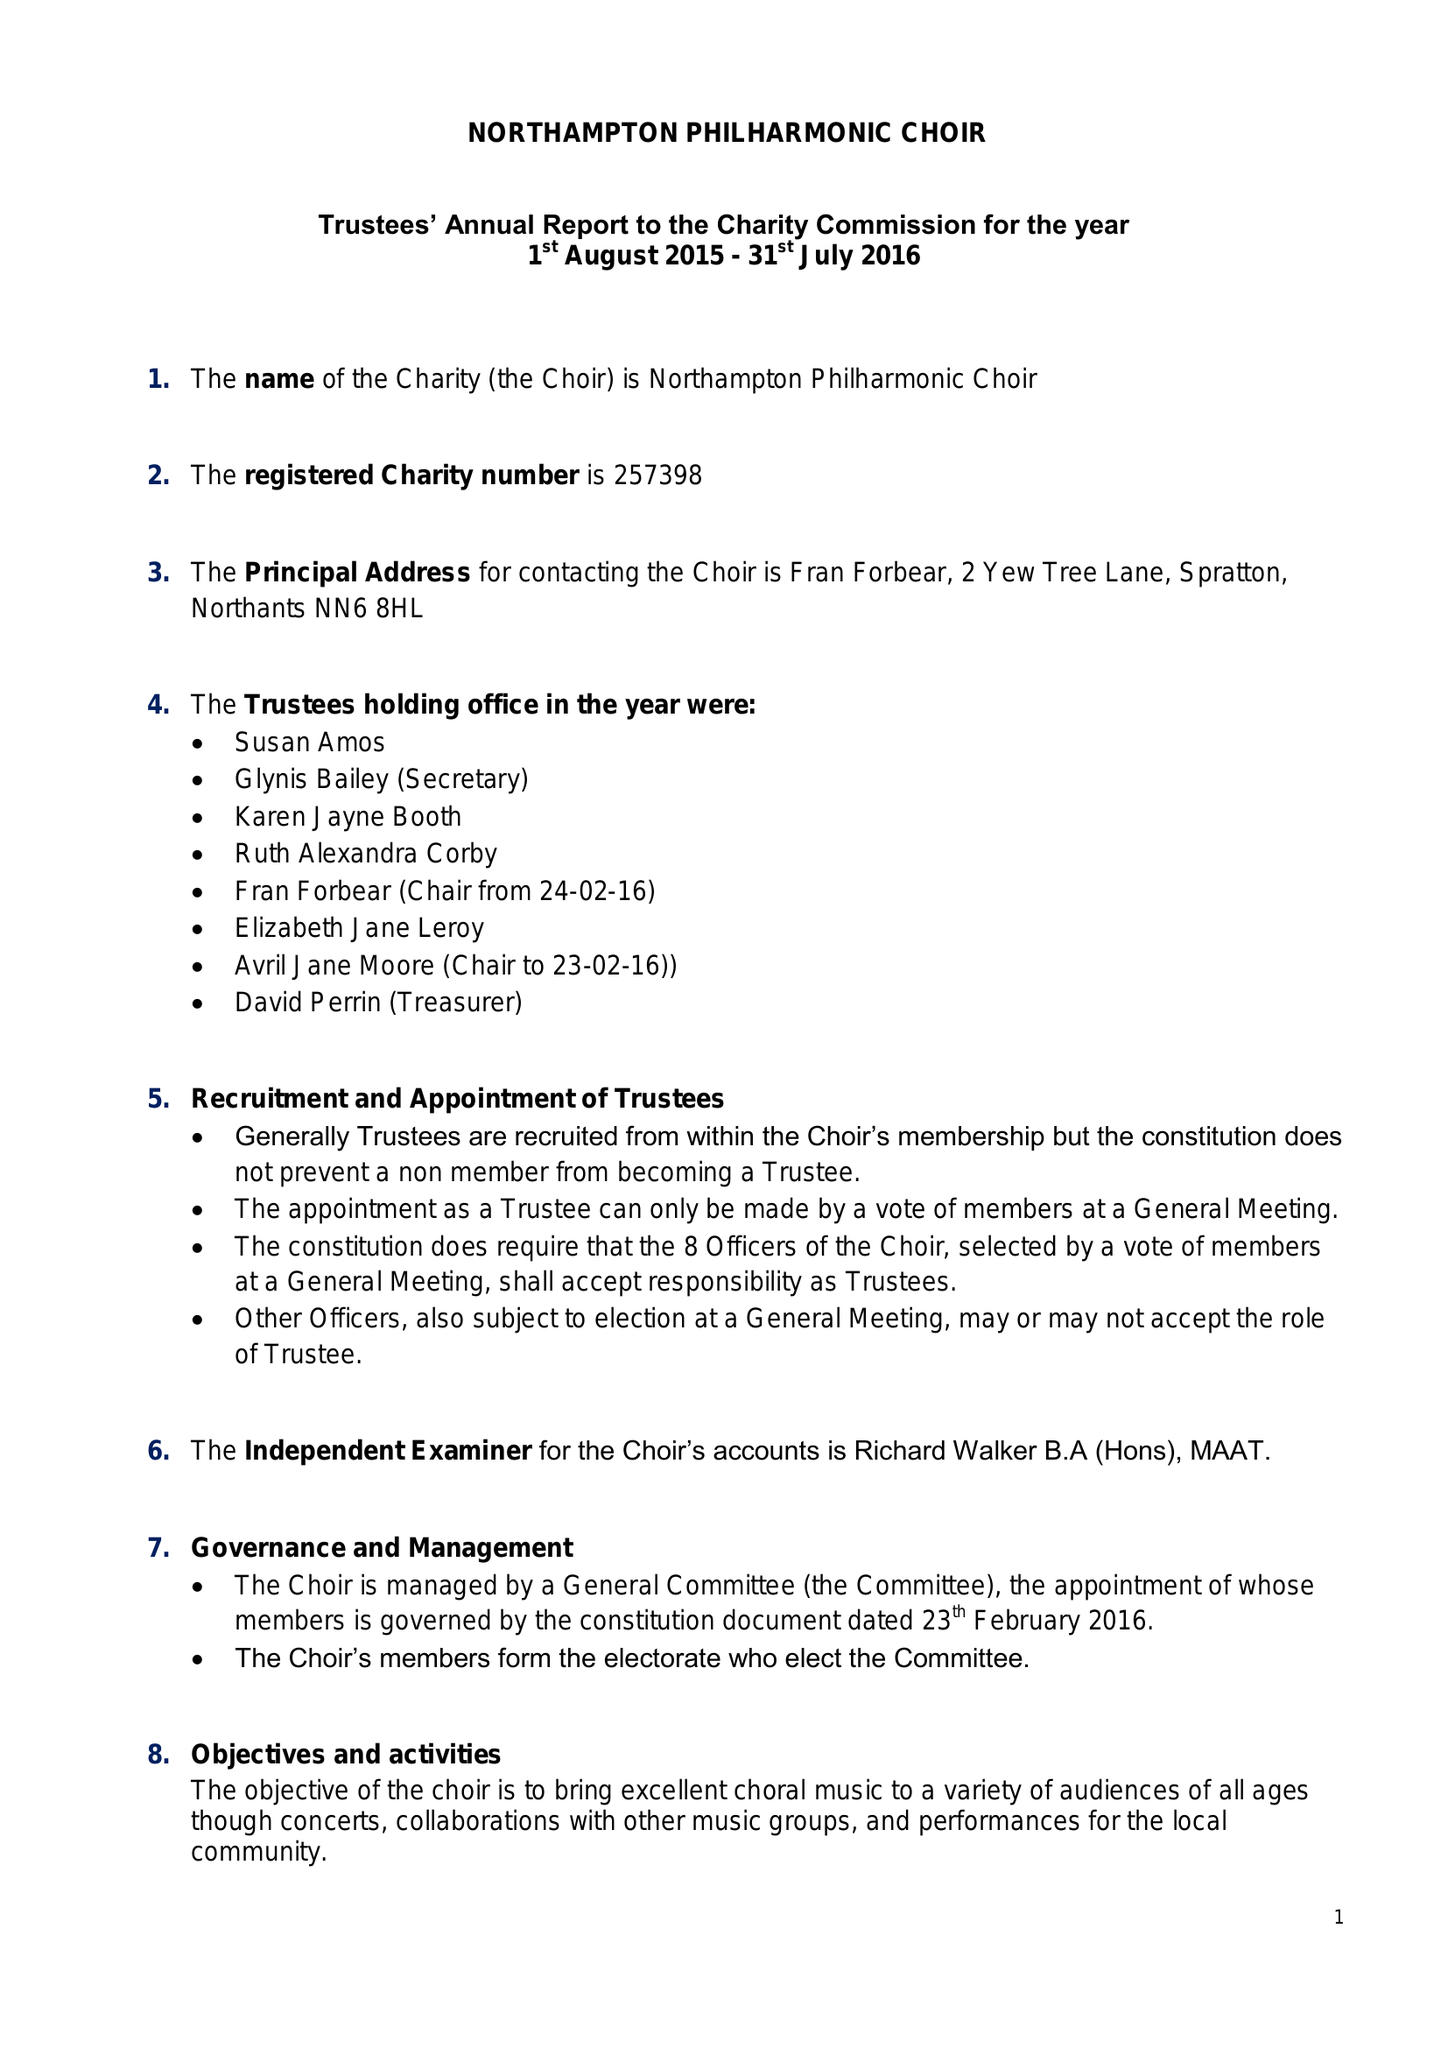What is the value for the address__post_town?
Answer the question using a single word or phrase. NORTHAMPTON 